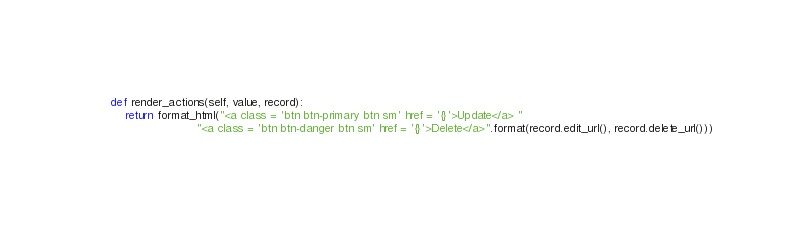Convert code to text. <code><loc_0><loc_0><loc_500><loc_500><_Python_>
    def render_actions(self, value, record):
        return format_html("<a class = 'btn btn-primary btn sm' href = '{}'>Update</a> "
                            "<a class = 'btn btn-danger btn sm' href = '{}'>Delete</a>".format(record.edit_url(), record.delete_url()))</code> 